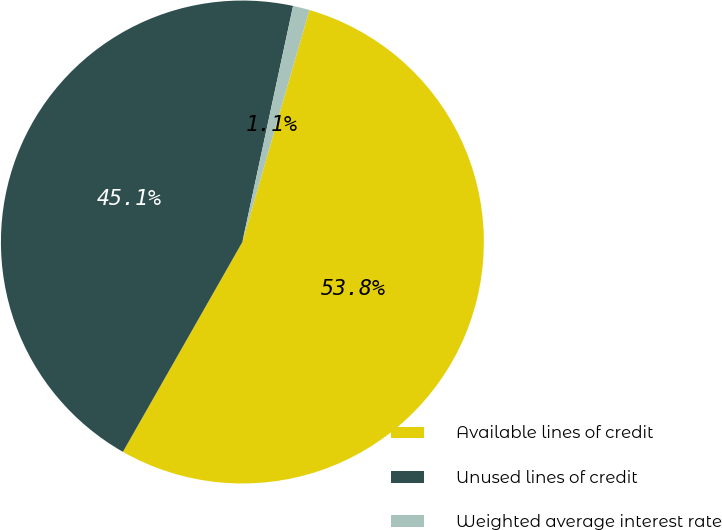Convert chart to OTSL. <chart><loc_0><loc_0><loc_500><loc_500><pie_chart><fcel>Available lines of credit<fcel>Unused lines of credit<fcel>Weighted average interest rate<nl><fcel>53.76%<fcel>45.13%<fcel>1.11%<nl></chart> 